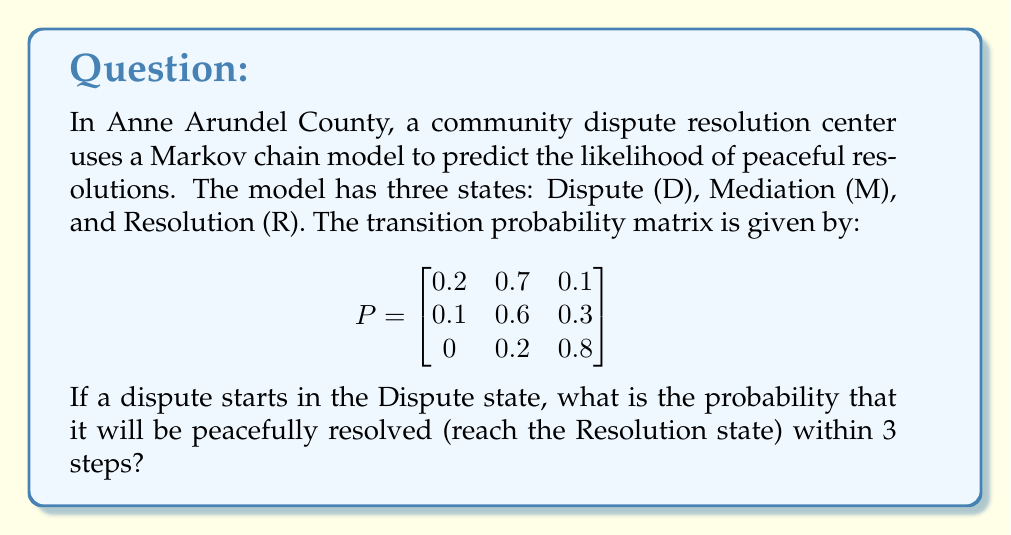Give your solution to this math problem. To solve this problem, we need to calculate the 3-step transition probability from the Dispute state to the Resolution state. We can do this by raising the transition probability matrix to the power of 3 and looking at the entry in the first row, third column.

Step 1: Calculate $P^2$
$$P^2 = \begin{bmatrix}
0.2 & 0.7 & 0.1 \\
0.1 & 0.6 & 0.3 \\
0 & 0.2 & 0.8
\end{bmatrix} \times \begin{bmatrix}
0.2 & 0.7 & 0.1 \\
0.1 & 0.6 & 0.3 \\
0 & 0.2 & 0.8
\end{bmatrix}$$

$$P^2 = \begin{bmatrix}
0.13 & 0.62 & 0.25 \\
0.08 & 0.52 & 0.40 \\
0.02 & 0.32 & 0.66
\end{bmatrix}$$

Step 2: Calculate $P^3$
$$P^3 = P^2 \times P = \begin{bmatrix}
0.13 & 0.62 & 0.25 \\
0.08 & 0.52 & 0.40 \\
0.02 & 0.32 & 0.66
\end{bmatrix} \times \begin{bmatrix}
0.2 & 0.7 & 0.1 \\
0.1 & 0.6 & 0.3 \\
0 & 0.2 & 0.8
\end{bmatrix}$$

$$P^3 = \begin{bmatrix}
0.101 & 0.554 & 0.345 \\
0.068 & 0.464 & 0.468 \\
0.024 & 0.368 & 0.608
\end{bmatrix}$$

Step 3: Interpret the result
The probability of reaching the Resolution state from the Dispute state in exactly 3 steps is given by the entry in the first row, third column of $P^3$, which is 0.345 or 34.5%.
Answer: 0.345 